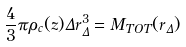<formula> <loc_0><loc_0><loc_500><loc_500>\frac { 4 } { 3 } \pi \rho _ { c } ( z ) \Delta r ^ { 3 } _ { \Delta } = M _ { T O T } ( r _ { \Delta } )</formula> 